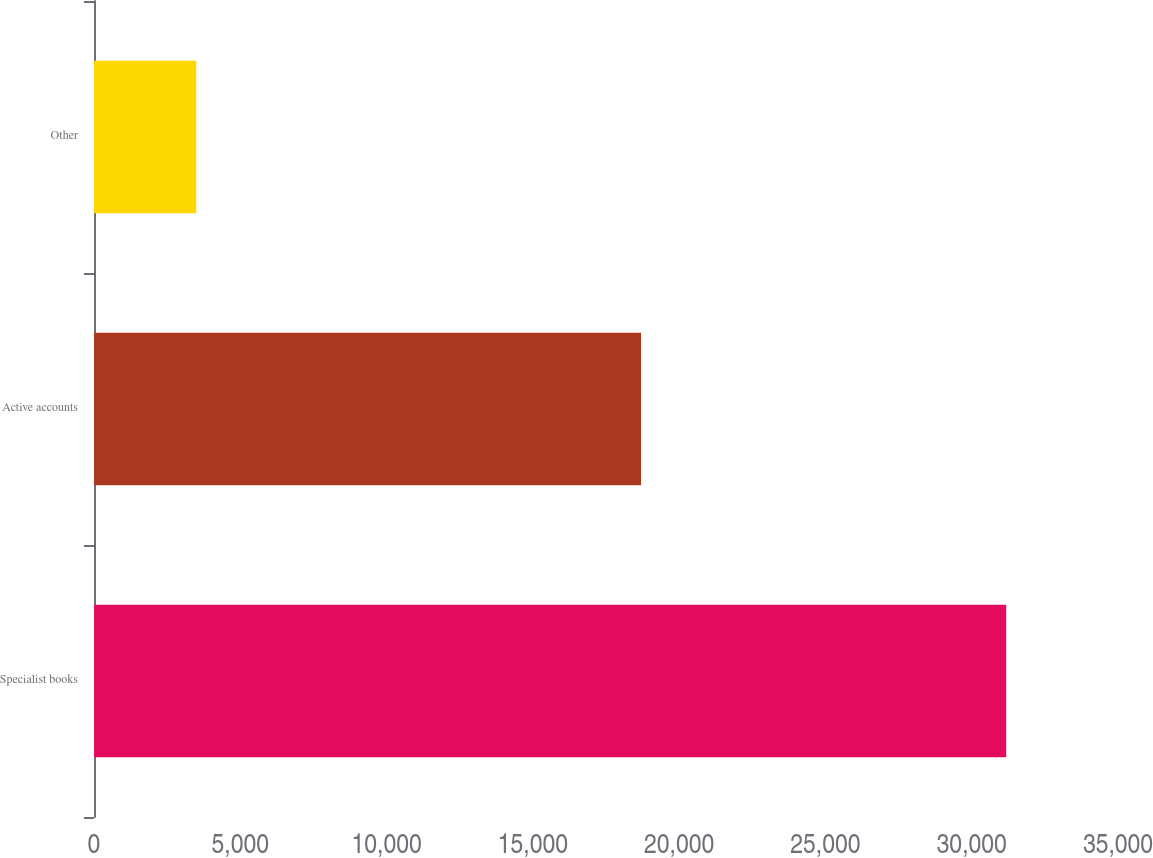Convert chart to OTSL. <chart><loc_0><loc_0><loc_500><loc_500><bar_chart><fcel>Specialist books<fcel>Active accounts<fcel>Other<nl><fcel>31179<fcel>18698<fcel>3493<nl></chart> 